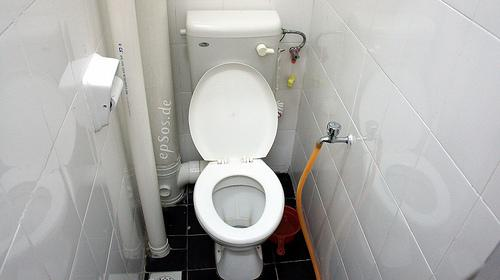Question: what is the predominant item in this picture?
Choices:
A. A toilet.
B. A sink.
C. A bath tub.
D. A Shower Stall.
Answer with the letter. Answer: A Question: why does one use a toilet?
Choices:
A. To void bowels.
B. To relieve self.
C. To stay clean.
D. To deposit human waste in a clean way.
Answer with the letter. Answer: D Question: where is the toilet paper?
Choices:
A. To the left.
B. To the right.
C. Behind the toilet.
D. Next to the toilet.
Answer with the letter. Answer: A Question: what color is the toilet?
Choices:
A. Gray.
B. Black.
C. It is white.
D. Silver.
Answer with the letter. Answer: C Question: what is in the toilet bowl?
Choices:
A. Water.
B. Blue Cleaner.
C. Toilet Paper.
D. Nothing.
Answer with the letter. Answer: A 